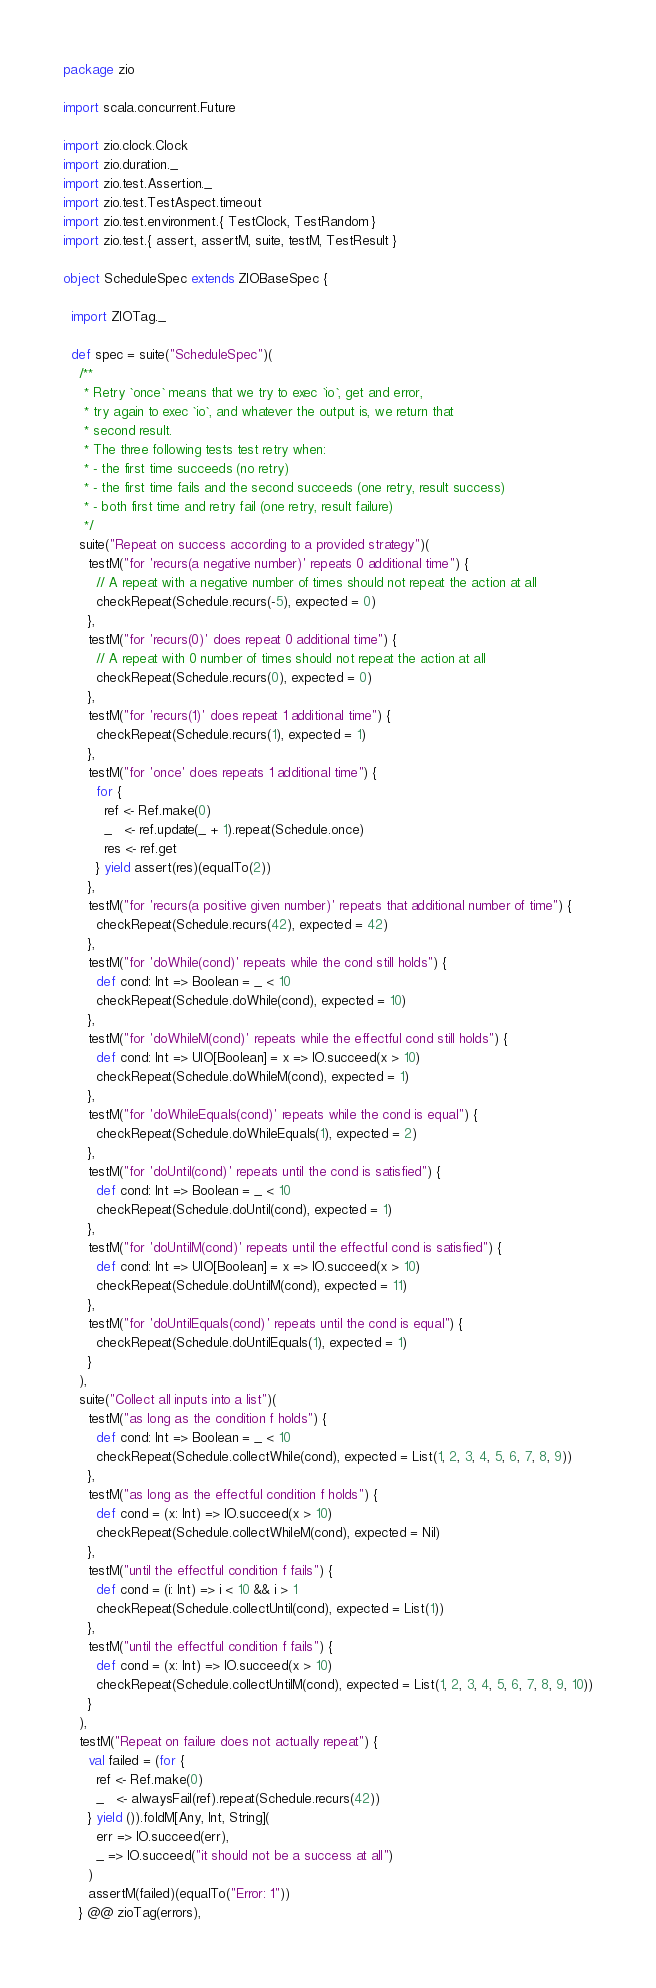Convert code to text. <code><loc_0><loc_0><loc_500><loc_500><_Scala_>package zio

import scala.concurrent.Future

import zio.clock.Clock
import zio.duration._
import zio.test.Assertion._
import zio.test.TestAspect.timeout
import zio.test.environment.{ TestClock, TestRandom }
import zio.test.{ assert, assertM, suite, testM, TestResult }

object ScheduleSpec extends ZIOBaseSpec {

  import ZIOTag._

  def spec = suite("ScheduleSpec")(
    /**
     * Retry `once` means that we try to exec `io`, get and error,
     * try again to exec `io`, and whatever the output is, we return that
     * second result.
     * The three following tests test retry when:
     * - the first time succeeds (no retry)
     * - the first time fails and the second succeeds (one retry, result success)
     * - both first time and retry fail (one retry, result failure)
     */
    suite("Repeat on success according to a provided strategy")(
      testM("for 'recurs(a negative number)' repeats 0 additional time") {
        // A repeat with a negative number of times should not repeat the action at all
        checkRepeat(Schedule.recurs(-5), expected = 0)
      },
      testM("for 'recurs(0)' does repeat 0 additional time") {
        // A repeat with 0 number of times should not repeat the action at all
        checkRepeat(Schedule.recurs(0), expected = 0)
      },
      testM("for 'recurs(1)' does repeat 1 additional time") {
        checkRepeat(Schedule.recurs(1), expected = 1)
      },
      testM("for 'once' does repeats 1 additional time") {
        for {
          ref <- Ref.make(0)
          _   <- ref.update(_ + 1).repeat(Schedule.once)
          res <- ref.get
        } yield assert(res)(equalTo(2))
      },
      testM("for 'recurs(a positive given number)' repeats that additional number of time") {
        checkRepeat(Schedule.recurs(42), expected = 42)
      },
      testM("for 'doWhile(cond)' repeats while the cond still holds") {
        def cond: Int => Boolean = _ < 10
        checkRepeat(Schedule.doWhile(cond), expected = 10)
      },
      testM("for 'doWhileM(cond)' repeats while the effectful cond still holds") {
        def cond: Int => UIO[Boolean] = x => IO.succeed(x > 10)
        checkRepeat(Schedule.doWhileM(cond), expected = 1)
      },
      testM("for 'doWhileEquals(cond)' repeats while the cond is equal") {
        checkRepeat(Schedule.doWhileEquals(1), expected = 2)
      },
      testM("for 'doUntil(cond)' repeats until the cond is satisfied") {
        def cond: Int => Boolean = _ < 10
        checkRepeat(Schedule.doUntil(cond), expected = 1)
      },
      testM("for 'doUntilM(cond)' repeats until the effectful cond is satisfied") {
        def cond: Int => UIO[Boolean] = x => IO.succeed(x > 10)
        checkRepeat(Schedule.doUntilM(cond), expected = 11)
      },
      testM("for 'doUntilEquals(cond)' repeats until the cond is equal") {
        checkRepeat(Schedule.doUntilEquals(1), expected = 1)
      }
    ),
    suite("Collect all inputs into a list")(
      testM("as long as the condition f holds") {
        def cond: Int => Boolean = _ < 10
        checkRepeat(Schedule.collectWhile(cond), expected = List(1, 2, 3, 4, 5, 6, 7, 8, 9))
      },
      testM("as long as the effectful condition f holds") {
        def cond = (x: Int) => IO.succeed(x > 10)
        checkRepeat(Schedule.collectWhileM(cond), expected = Nil)
      },
      testM("until the effectful condition f fails") {
        def cond = (i: Int) => i < 10 && i > 1
        checkRepeat(Schedule.collectUntil(cond), expected = List(1))
      },
      testM("until the effectful condition f fails") {
        def cond = (x: Int) => IO.succeed(x > 10)
        checkRepeat(Schedule.collectUntilM(cond), expected = List(1, 2, 3, 4, 5, 6, 7, 8, 9, 10))
      }
    ),
    testM("Repeat on failure does not actually repeat") {
      val failed = (for {
        ref <- Ref.make(0)
        _   <- alwaysFail(ref).repeat(Schedule.recurs(42))
      } yield ()).foldM[Any, Int, String](
        err => IO.succeed(err),
        _ => IO.succeed("it should not be a success at all")
      )
      assertM(failed)(equalTo("Error: 1"))
    } @@ zioTag(errors),</code> 